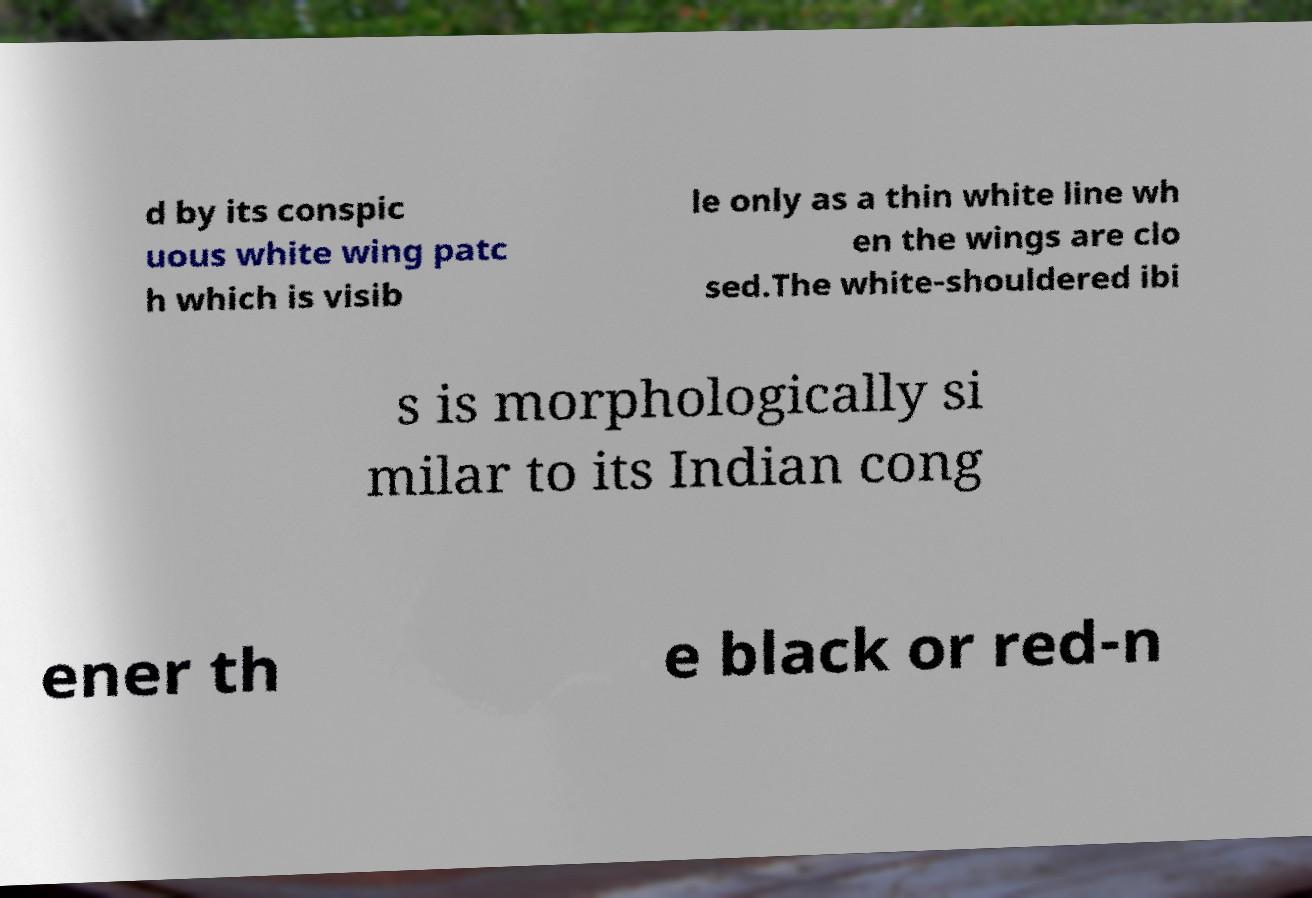Can you accurately transcribe the text from the provided image for me? d by its conspic uous white wing patc h which is visib le only as a thin white line wh en the wings are clo sed.The white-shouldered ibi s is morphologically si milar to its Indian cong ener th e black or red-n 